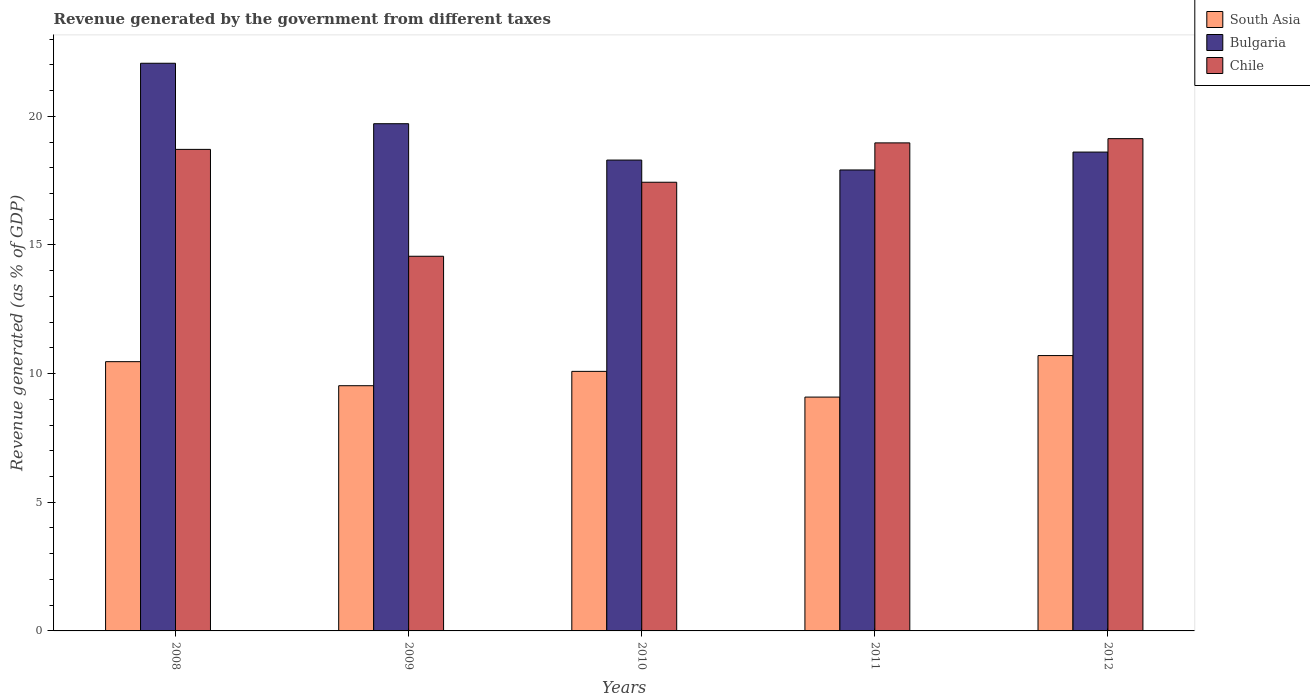How many bars are there on the 2nd tick from the right?
Give a very brief answer. 3. In how many cases, is the number of bars for a given year not equal to the number of legend labels?
Make the answer very short. 0. What is the revenue generated by the government in Bulgaria in 2008?
Your response must be concise. 22.06. Across all years, what is the maximum revenue generated by the government in Bulgaria?
Your response must be concise. 22.06. Across all years, what is the minimum revenue generated by the government in Bulgaria?
Give a very brief answer. 17.91. What is the total revenue generated by the government in Bulgaria in the graph?
Offer a very short reply. 96.59. What is the difference between the revenue generated by the government in Bulgaria in 2009 and that in 2012?
Offer a terse response. 1.1. What is the difference between the revenue generated by the government in Bulgaria in 2008 and the revenue generated by the government in South Asia in 2010?
Offer a very short reply. 11.97. What is the average revenue generated by the government in Chile per year?
Your answer should be compact. 17.76. In the year 2010, what is the difference between the revenue generated by the government in Bulgaria and revenue generated by the government in Chile?
Your answer should be compact. 0.86. In how many years, is the revenue generated by the government in Chile greater than 7 %?
Your response must be concise. 5. What is the ratio of the revenue generated by the government in Chile in 2008 to that in 2010?
Ensure brevity in your answer.  1.07. What is the difference between the highest and the second highest revenue generated by the government in Chile?
Provide a succinct answer. 0.16. What is the difference between the highest and the lowest revenue generated by the government in Chile?
Make the answer very short. 4.57. In how many years, is the revenue generated by the government in South Asia greater than the average revenue generated by the government in South Asia taken over all years?
Your answer should be compact. 3. What does the 3rd bar from the right in 2008 represents?
Give a very brief answer. South Asia. How many bars are there?
Offer a terse response. 15. Does the graph contain grids?
Offer a very short reply. No. Where does the legend appear in the graph?
Your answer should be compact. Top right. What is the title of the graph?
Your answer should be compact. Revenue generated by the government from different taxes. What is the label or title of the X-axis?
Your response must be concise. Years. What is the label or title of the Y-axis?
Your response must be concise. Revenue generated (as % of GDP). What is the Revenue generated (as % of GDP) of South Asia in 2008?
Provide a short and direct response. 10.46. What is the Revenue generated (as % of GDP) of Bulgaria in 2008?
Give a very brief answer. 22.06. What is the Revenue generated (as % of GDP) in Chile in 2008?
Offer a very short reply. 18.71. What is the Revenue generated (as % of GDP) in South Asia in 2009?
Your answer should be very brief. 9.53. What is the Revenue generated (as % of GDP) in Bulgaria in 2009?
Offer a terse response. 19.71. What is the Revenue generated (as % of GDP) in Chile in 2009?
Make the answer very short. 14.56. What is the Revenue generated (as % of GDP) of South Asia in 2010?
Provide a succinct answer. 10.09. What is the Revenue generated (as % of GDP) in Bulgaria in 2010?
Give a very brief answer. 18.3. What is the Revenue generated (as % of GDP) in Chile in 2010?
Keep it short and to the point. 17.44. What is the Revenue generated (as % of GDP) of South Asia in 2011?
Provide a succinct answer. 9.09. What is the Revenue generated (as % of GDP) in Bulgaria in 2011?
Keep it short and to the point. 17.91. What is the Revenue generated (as % of GDP) of Chile in 2011?
Offer a very short reply. 18.97. What is the Revenue generated (as % of GDP) in South Asia in 2012?
Your answer should be very brief. 10.7. What is the Revenue generated (as % of GDP) of Bulgaria in 2012?
Your answer should be compact. 18.61. What is the Revenue generated (as % of GDP) of Chile in 2012?
Make the answer very short. 19.13. Across all years, what is the maximum Revenue generated (as % of GDP) in South Asia?
Make the answer very short. 10.7. Across all years, what is the maximum Revenue generated (as % of GDP) of Bulgaria?
Offer a terse response. 22.06. Across all years, what is the maximum Revenue generated (as % of GDP) of Chile?
Your answer should be very brief. 19.13. Across all years, what is the minimum Revenue generated (as % of GDP) in South Asia?
Ensure brevity in your answer.  9.09. Across all years, what is the minimum Revenue generated (as % of GDP) of Bulgaria?
Offer a very short reply. 17.91. Across all years, what is the minimum Revenue generated (as % of GDP) in Chile?
Ensure brevity in your answer.  14.56. What is the total Revenue generated (as % of GDP) in South Asia in the graph?
Your answer should be compact. 49.87. What is the total Revenue generated (as % of GDP) of Bulgaria in the graph?
Provide a succinct answer. 96.59. What is the total Revenue generated (as % of GDP) of Chile in the graph?
Give a very brief answer. 88.81. What is the difference between the Revenue generated (as % of GDP) of South Asia in 2008 and that in 2009?
Your answer should be compact. 0.93. What is the difference between the Revenue generated (as % of GDP) of Bulgaria in 2008 and that in 2009?
Your answer should be compact. 2.35. What is the difference between the Revenue generated (as % of GDP) in Chile in 2008 and that in 2009?
Offer a very short reply. 4.15. What is the difference between the Revenue generated (as % of GDP) in South Asia in 2008 and that in 2010?
Provide a succinct answer. 0.38. What is the difference between the Revenue generated (as % of GDP) of Bulgaria in 2008 and that in 2010?
Offer a terse response. 3.76. What is the difference between the Revenue generated (as % of GDP) in Chile in 2008 and that in 2010?
Provide a short and direct response. 1.28. What is the difference between the Revenue generated (as % of GDP) of South Asia in 2008 and that in 2011?
Make the answer very short. 1.38. What is the difference between the Revenue generated (as % of GDP) of Bulgaria in 2008 and that in 2011?
Offer a very short reply. 4.15. What is the difference between the Revenue generated (as % of GDP) in Chile in 2008 and that in 2011?
Your answer should be compact. -0.25. What is the difference between the Revenue generated (as % of GDP) of South Asia in 2008 and that in 2012?
Ensure brevity in your answer.  -0.24. What is the difference between the Revenue generated (as % of GDP) of Bulgaria in 2008 and that in 2012?
Offer a terse response. 3.45. What is the difference between the Revenue generated (as % of GDP) of Chile in 2008 and that in 2012?
Make the answer very short. -0.42. What is the difference between the Revenue generated (as % of GDP) in South Asia in 2009 and that in 2010?
Offer a very short reply. -0.56. What is the difference between the Revenue generated (as % of GDP) of Bulgaria in 2009 and that in 2010?
Offer a terse response. 1.41. What is the difference between the Revenue generated (as % of GDP) in Chile in 2009 and that in 2010?
Your answer should be compact. -2.88. What is the difference between the Revenue generated (as % of GDP) in South Asia in 2009 and that in 2011?
Provide a succinct answer. 0.44. What is the difference between the Revenue generated (as % of GDP) of Bulgaria in 2009 and that in 2011?
Your answer should be compact. 1.8. What is the difference between the Revenue generated (as % of GDP) of Chile in 2009 and that in 2011?
Your response must be concise. -4.41. What is the difference between the Revenue generated (as % of GDP) in South Asia in 2009 and that in 2012?
Your answer should be very brief. -1.17. What is the difference between the Revenue generated (as % of GDP) in Bulgaria in 2009 and that in 2012?
Keep it short and to the point. 1.1. What is the difference between the Revenue generated (as % of GDP) of Chile in 2009 and that in 2012?
Provide a short and direct response. -4.57. What is the difference between the Revenue generated (as % of GDP) in South Asia in 2010 and that in 2011?
Ensure brevity in your answer.  1. What is the difference between the Revenue generated (as % of GDP) of Bulgaria in 2010 and that in 2011?
Provide a short and direct response. 0.38. What is the difference between the Revenue generated (as % of GDP) in Chile in 2010 and that in 2011?
Make the answer very short. -1.53. What is the difference between the Revenue generated (as % of GDP) in South Asia in 2010 and that in 2012?
Your answer should be very brief. -0.61. What is the difference between the Revenue generated (as % of GDP) in Bulgaria in 2010 and that in 2012?
Give a very brief answer. -0.31. What is the difference between the Revenue generated (as % of GDP) in Chile in 2010 and that in 2012?
Your answer should be compact. -1.69. What is the difference between the Revenue generated (as % of GDP) of South Asia in 2011 and that in 2012?
Keep it short and to the point. -1.61. What is the difference between the Revenue generated (as % of GDP) of Bulgaria in 2011 and that in 2012?
Your answer should be very brief. -0.69. What is the difference between the Revenue generated (as % of GDP) in Chile in 2011 and that in 2012?
Your answer should be very brief. -0.16. What is the difference between the Revenue generated (as % of GDP) in South Asia in 2008 and the Revenue generated (as % of GDP) in Bulgaria in 2009?
Offer a terse response. -9.25. What is the difference between the Revenue generated (as % of GDP) of South Asia in 2008 and the Revenue generated (as % of GDP) of Chile in 2009?
Ensure brevity in your answer.  -4.1. What is the difference between the Revenue generated (as % of GDP) of Bulgaria in 2008 and the Revenue generated (as % of GDP) of Chile in 2009?
Offer a very short reply. 7.5. What is the difference between the Revenue generated (as % of GDP) of South Asia in 2008 and the Revenue generated (as % of GDP) of Bulgaria in 2010?
Offer a terse response. -7.83. What is the difference between the Revenue generated (as % of GDP) of South Asia in 2008 and the Revenue generated (as % of GDP) of Chile in 2010?
Offer a very short reply. -6.97. What is the difference between the Revenue generated (as % of GDP) of Bulgaria in 2008 and the Revenue generated (as % of GDP) of Chile in 2010?
Keep it short and to the point. 4.62. What is the difference between the Revenue generated (as % of GDP) of South Asia in 2008 and the Revenue generated (as % of GDP) of Bulgaria in 2011?
Make the answer very short. -7.45. What is the difference between the Revenue generated (as % of GDP) of South Asia in 2008 and the Revenue generated (as % of GDP) of Chile in 2011?
Your answer should be very brief. -8.5. What is the difference between the Revenue generated (as % of GDP) in Bulgaria in 2008 and the Revenue generated (as % of GDP) in Chile in 2011?
Offer a terse response. 3.09. What is the difference between the Revenue generated (as % of GDP) in South Asia in 2008 and the Revenue generated (as % of GDP) in Bulgaria in 2012?
Your response must be concise. -8.14. What is the difference between the Revenue generated (as % of GDP) of South Asia in 2008 and the Revenue generated (as % of GDP) of Chile in 2012?
Make the answer very short. -8.67. What is the difference between the Revenue generated (as % of GDP) in Bulgaria in 2008 and the Revenue generated (as % of GDP) in Chile in 2012?
Keep it short and to the point. 2.93. What is the difference between the Revenue generated (as % of GDP) in South Asia in 2009 and the Revenue generated (as % of GDP) in Bulgaria in 2010?
Provide a short and direct response. -8.77. What is the difference between the Revenue generated (as % of GDP) in South Asia in 2009 and the Revenue generated (as % of GDP) in Chile in 2010?
Offer a very short reply. -7.91. What is the difference between the Revenue generated (as % of GDP) in Bulgaria in 2009 and the Revenue generated (as % of GDP) in Chile in 2010?
Offer a very short reply. 2.27. What is the difference between the Revenue generated (as % of GDP) in South Asia in 2009 and the Revenue generated (as % of GDP) in Bulgaria in 2011?
Offer a terse response. -8.38. What is the difference between the Revenue generated (as % of GDP) in South Asia in 2009 and the Revenue generated (as % of GDP) in Chile in 2011?
Provide a short and direct response. -9.44. What is the difference between the Revenue generated (as % of GDP) in Bulgaria in 2009 and the Revenue generated (as % of GDP) in Chile in 2011?
Keep it short and to the point. 0.74. What is the difference between the Revenue generated (as % of GDP) in South Asia in 2009 and the Revenue generated (as % of GDP) in Bulgaria in 2012?
Your answer should be compact. -9.08. What is the difference between the Revenue generated (as % of GDP) of South Asia in 2009 and the Revenue generated (as % of GDP) of Chile in 2012?
Your response must be concise. -9.6. What is the difference between the Revenue generated (as % of GDP) of Bulgaria in 2009 and the Revenue generated (as % of GDP) of Chile in 2012?
Your answer should be very brief. 0.58. What is the difference between the Revenue generated (as % of GDP) of South Asia in 2010 and the Revenue generated (as % of GDP) of Bulgaria in 2011?
Your answer should be compact. -7.83. What is the difference between the Revenue generated (as % of GDP) in South Asia in 2010 and the Revenue generated (as % of GDP) in Chile in 2011?
Ensure brevity in your answer.  -8.88. What is the difference between the Revenue generated (as % of GDP) of Bulgaria in 2010 and the Revenue generated (as % of GDP) of Chile in 2011?
Your answer should be compact. -0.67. What is the difference between the Revenue generated (as % of GDP) in South Asia in 2010 and the Revenue generated (as % of GDP) in Bulgaria in 2012?
Offer a very short reply. -8.52. What is the difference between the Revenue generated (as % of GDP) in South Asia in 2010 and the Revenue generated (as % of GDP) in Chile in 2012?
Make the answer very short. -9.04. What is the difference between the Revenue generated (as % of GDP) of Bulgaria in 2010 and the Revenue generated (as % of GDP) of Chile in 2012?
Provide a succinct answer. -0.83. What is the difference between the Revenue generated (as % of GDP) of South Asia in 2011 and the Revenue generated (as % of GDP) of Bulgaria in 2012?
Your answer should be compact. -9.52. What is the difference between the Revenue generated (as % of GDP) of South Asia in 2011 and the Revenue generated (as % of GDP) of Chile in 2012?
Provide a succinct answer. -10.04. What is the difference between the Revenue generated (as % of GDP) of Bulgaria in 2011 and the Revenue generated (as % of GDP) of Chile in 2012?
Keep it short and to the point. -1.22. What is the average Revenue generated (as % of GDP) in South Asia per year?
Your response must be concise. 9.97. What is the average Revenue generated (as % of GDP) of Bulgaria per year?
Offer a very short reply. 19.32. What is the average Revenue generated (as % of GDP) in Chile per year?
Your response must be concise. 17.76. In the year 2008, what is the difference between the Revenue generated (as % of GDP) in South Asia and Revenue generated (as % of GDP) in Bulgaria?
Make the answer very short. -11.6. In the year 2008, what is the difference between the Revenue generated (as % of GDP) of South Asia and Revenue generated (as % of GDP) of Chile?
Provide a short and direct response. -8.25. In the year 2008, what is the difference between the Revenue generated (as % of GDP) of Bulgaria and Revenue generated (as % of GDP) of Chile?
Offer a terse response. 3.35. In the year 2009, what is the difference between the Revenue generated (as % of GDP) in South Asia and Revenue generated (as % of GDP) in Bulgaria?
Your answer should be very brief. -10.18. In the year 2009, what is the difference between the Revenue generated (as % of GDP) in South Asia and Revenue generated (as % of GDP) in Chile?
Provide a succinct answer. -5.03. In the year 2009, what is the difference between the Revenue generated (as % of GDP) in Bulgaria and Revenue generated (as % of GDP) in Chile?
Your response must be concise. 5.15. In the year 2010, what is the difference between the Revenue generated (as % of GDP) of South Asia and Revenue generated (as % of GDP) of Bulgaria?
Keep it short and to the point. -8.21. In the year 2010, what is the difference between the Revenue generated (as % of GDP) in South Asia and Revenue generated (as % of GDP) in Chile?
Your response must be concise. -7.35. In the year 2010, what is the difference between the Revenue generated (as % of GDP) of Bulgaria and Revenue generated (as % of GDP) of Chile?
Offer a very short reply. 0.86. In the year 2011, what is the difference between the Revenue generated (as % of GDP) of South Asia and Revenue generated (as % of GDP) of Bulgaria?
Your answer should be compact. -8.83. In the year 2011, what is the difference between the Revenue generated (as % of GDP) of South Asia and Revenue generated (as % of GDP) of Chile?
Offer a very short reply. -9.88. In the year 2011, what is the difference between the Revenue generated (as % of GDP) in Bulgaria and Revenue generated (as % of GDP) in Chile?
Your answer should be very brief. -1.05. In the year 2012, what is the difference between the Revenue generated (as % of GDP) in South Asia and Revenue generated (as % of GDP) in Bulgaria?
Your answer should be very brief. -7.91. In the year 2012, what is the difference between the Revenue generated (as % of GDP) of South Asia and Revenue generated (as % of GDP) of Chile?
Give a very brief answer. -8.43. In the year 2012, what is the difference between the Revenue generated (as % of GDP) of Bulgaria and Revenue generated (as % of GDP) of Chile?
Make the answer very short. -0.52. What is the ratio of the Revenue generated (as % of GDP) in South Asia in 2008 to that in 2009?
Make the answer very short. 1.1. What is the ratio of the Revenue generated (as % of GDP) of Bulgaria in 2008 to that in 2009?
Provide a succinct answer. 1.12. What is the ratio of the Revenue generated (as % of GDP) of Chile in 2008 to that in 2009?
Make the answer very short. 1.29. What is the ratio of the Revenue generated (as % of GDP) in South Asia in 2008 to that in 2010?
Your answer should be very brief. 1.04. What is the ratio of the Revenue generated (as % of GDP) of Bulgaria in 2008 to that in 2010?
Offer a very short reply. 1.21. What is the ratio of the Revenue generated (as % of GDP) of Chile in 2008 to that in 2010?
Your answer should be very brief. 1.07. What is the ratio of the Revenue generated (as % of GDP) of South Asia in 2008 to that in 2011?
Provide a short and direct response. 1.15. What is the ratio of the Revenue generated (as % of GDP) in Bulgaria in 2008 to that in 2011?
Provide a short and direct response. 1.23. What is the ratio of the Revenue generated (as % of GDP) of Chile in 2008 to that in 2011?
Your response must be concise. 0.99. What is the ratio of the Revenue generated (as % of GDP) in South Asia in 2008 to that in 2012?
Ensure brevity in your answer.  0.98. What is the ratio of the Revenue generated (as % of GDP) of Bulgaria in 2008 to that in 2012?
Ensure brevity in your answer.  1.19. What is the ratio of the Revenue generated (as % of GDP) of Chile in 2008 to that in 2012?
Provide a succinct answer. 0.98. What is the ratio of the Revenue generated (as % of GDP) of South Asia in 2009 to that in 2010?
Your answer should be very brief. 0.94. What is the ratio of the Revenue generated (as % of GDP) of Bulgaria in 2009 to that in 2010?
Ensure brevity in your answer.  1.08. What is the ratio of the Revenue generated (as % of GDP) in Chile in 2009 to that in 2010?
Your answer should be compact. 0.83. What is the ratio of the Revenue generated (as % of GDP) in South Asia in 2009 to that in 2011?
Make the answer very short. 1.05. What is the ratio of the Revenue generated (as % of GDP) in Bulgaria in 2009 to that in 2011?
Make the answer very short. 1.1. What is the ratio of the Revenue generated (as % of GDP) in Chile in 2009 to that in 2011?
Your answer should be compact. 0.77. What is the ratio of the Revenue generated (as % of GDP) in South Asia in 2009 to that in 2012?
Give a very brief answer. 0.89. What is the ratio of the Revenue generated (as % of GDP) of Bulgaria in 2009 to that in 2012?
Give a very brief answer. 1.06. What is the ratio of the Revenue generated (as % of GDP) in Chile in 2009 to that in 2012?
Your response must be concise. 0.76. What is the ratio of the Revenue generated (as % of GDP) of South Asia in 2010 to that in 2011?
Your response must be concise. 1.11. What is the ratio of the Revenue generated (as % of GDP) of Bulgaria in 2010 to that in 2011?
Give a very brief answer. 1.02. What is the ratio of the Revenue generated (as % of GDP) in Chile in 2010 to that in 2011?
Offer a terse response. 0.92. What is the ratio of the Revenue generated (as % of GDP) of South Asia in 2010 to that in 2012?
Keep it short and to the point. 0.94. What is the ratio of the Revenue generated (as % of GDP) in Bulgaria in 2010 to that in 2012?
Your answer should be compact. 0.98. What is the ratio of the Revenue generated (as % of GDP) in Chile in 2010 to that in 2012?
Your answer should be compact. 0.91. What is the ratio of the Revenue generated (as % of GDP) of South Asia in 2011 to that in 2012?
Ensure brevity in your answer.  0.85. What is the ratio of the Revenue generated (as % of GDP) in Bulgaria in 2011 to that in 2012?
Your answer should be very brief. 0.96. What is the ratio of the Revenue generated (as % of GDP) of Chile in 2011 to that in 2012?
Give a very brief answer. 0.99. What is the difference between the highest and the second highest Revenue generated (as % of GDP) of South Asia?
Ensure brevity in your answer.  0.24. What is the difference between the highest and the second highest Revenue generated (as % of GDP) in Bulgaria?
Offer a terse response. 2.35. What is the difference between the highest and the second highest Revenue generated (as % of GDP) of Chile?
Your answer should be compact. 0.16. What is the difference between the highest and the lowest Revenue generated (as % of GDP) of South Asia?
Your answer should be very brief. 1.61. What is the difference between the highest and the lowest Revenue generated (as % of GDP) of Bulgaria?
Make the answer very short. 4.15. What is the difference between the highest and the lowest Revenue generated (as % of GDP) of Chile?
Offer a terse response. 4.57. 